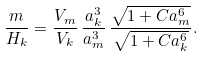<formula> <loc_0><loc_0><loc_500><loc_500>\frac { m } { H _ { k } } = \frac { V _ { m } } { V _ { k } } \, \frac { a _ { k } ^ { 3 } } { a _ { m } ^ { 3 } } \, \frac { \sqrt { 1 + C a _ { m } ^ { 6 } } } { \sqrt { 1 + C a _ { k } ^ { 6 } } } .</formula> 